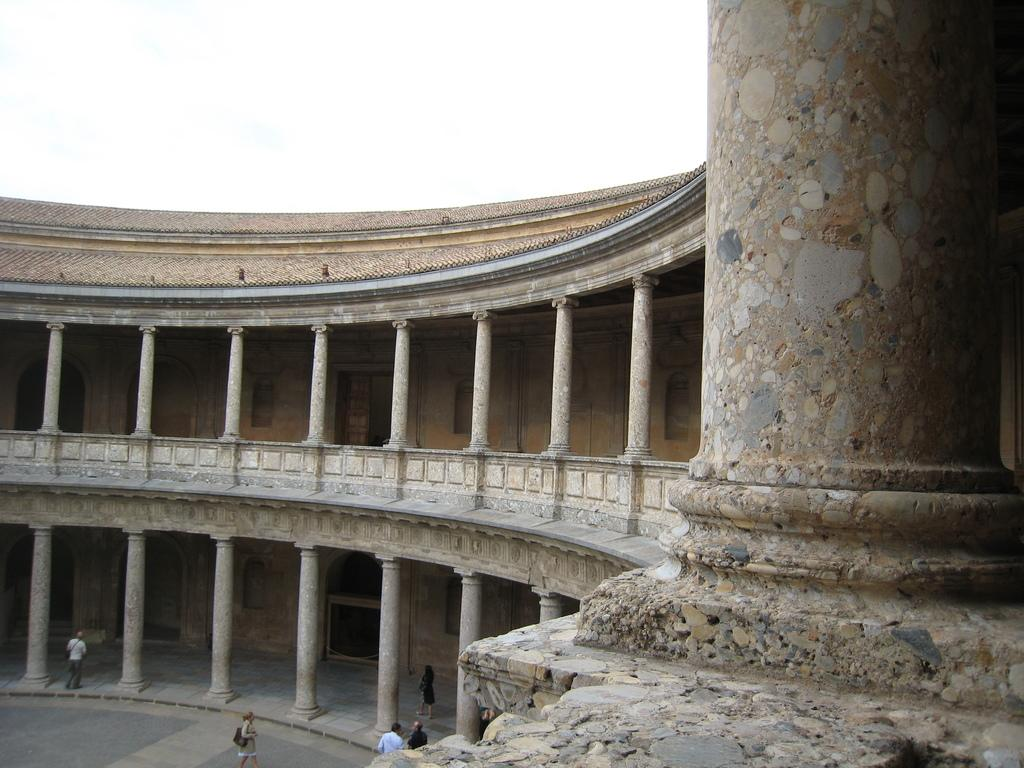What is the main subject of the image? The main subject of the image is a monument. What architectural features can be seen on the monument? There are pillars on the monument. Are there any people present in the image? Yes, there are people in the image. How would you describe the weather based on the image? The sky is cloudy in the image, suggesting a potentially overcast or cloudy day. What type of action is the monument performing in the image? Monuments are inanimate objects and do not perform actions. --- Facts: 1. There is a person holding a book in the image. 2. The person is sitting on a chair. 3. There is a table in the image. 4. The table has a lamp on it. 5. The background of the image is a bookshelf. Absurd Topics: dance, ocean, parrot Conversation: What is the person in the image doing? The person is holding a book in the image. Where is the person sitting? The person is sitting on a chair. What is on the table in the image? There is a lamp on the table in the image. What can be seen in the background of the image? The background of the image is a bookshelf. Reasoning: Let's think step by step in order to produce the conversation. We start by identifying the main subject of the image, which is the person holding a book. Then, we describe the person's position, noting that they are sitting on a chair. Next, we observe the presence of a table and its contents, which include a lamp. Finally, we describe the background of the image, which is a bookshelf. Absurd Question/Answer: Can you see any parrots flying over the ocean in the image? There is no ocean or parrot present in the image. 